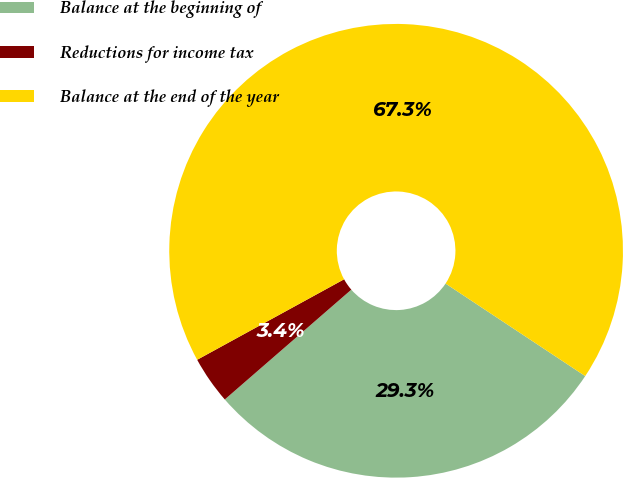<chart> <loc_0><loc_0><loc_500><loc_500><pie_chart><fcel>Balance at the beginning of<fcel>Reductions for income tax<fcel>Balance at the end of the year<nl><fcel>29.31%<fcel>3.4%<fcel>67.29%<nl></chart> 